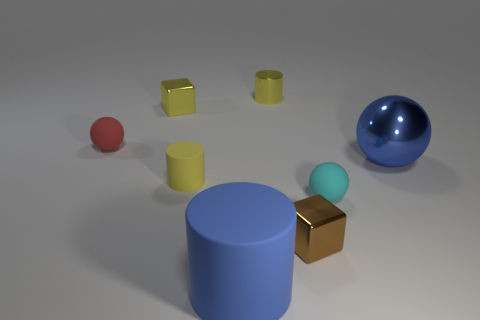The big metal object that is the same color as the big matte cylinder is what shape?
Ensure brevity in your answer.  Sphere. Do the blue rubber thing and the yellow object that is left of the yellow rubber cylinder have the same shape?
Your answer should be compact. No. Are there any cyan matte spheres behind the yellow cube?
Your answer should be compact. No. What is the material of the big ball that is the same color as the big cylinder?
Offer a very short reply. Metal. Is the size of the red ball the same as the metallic cube that is to the right of the yellow metal cylinder?
Keep it short and to the point. Yes. Are there any rubber cylinders of the same color as the big shiny object?
Make the answer very short. Yes. Is there a red thing that has the same shape as the cyan object?
Your answer should be compact. Yes. What shape is the thing that is in front of the cyan rubber sphere and on the right side of the blue rubber cylinder?
Offer a terse response. Cube. What number of large cylinders have the same material as the brown object?
Give a very brief answer. 0. Are there fewer cylinders on the left side of the big blue shiny object than blue shiny spheres?
Your response must be concise. No. 